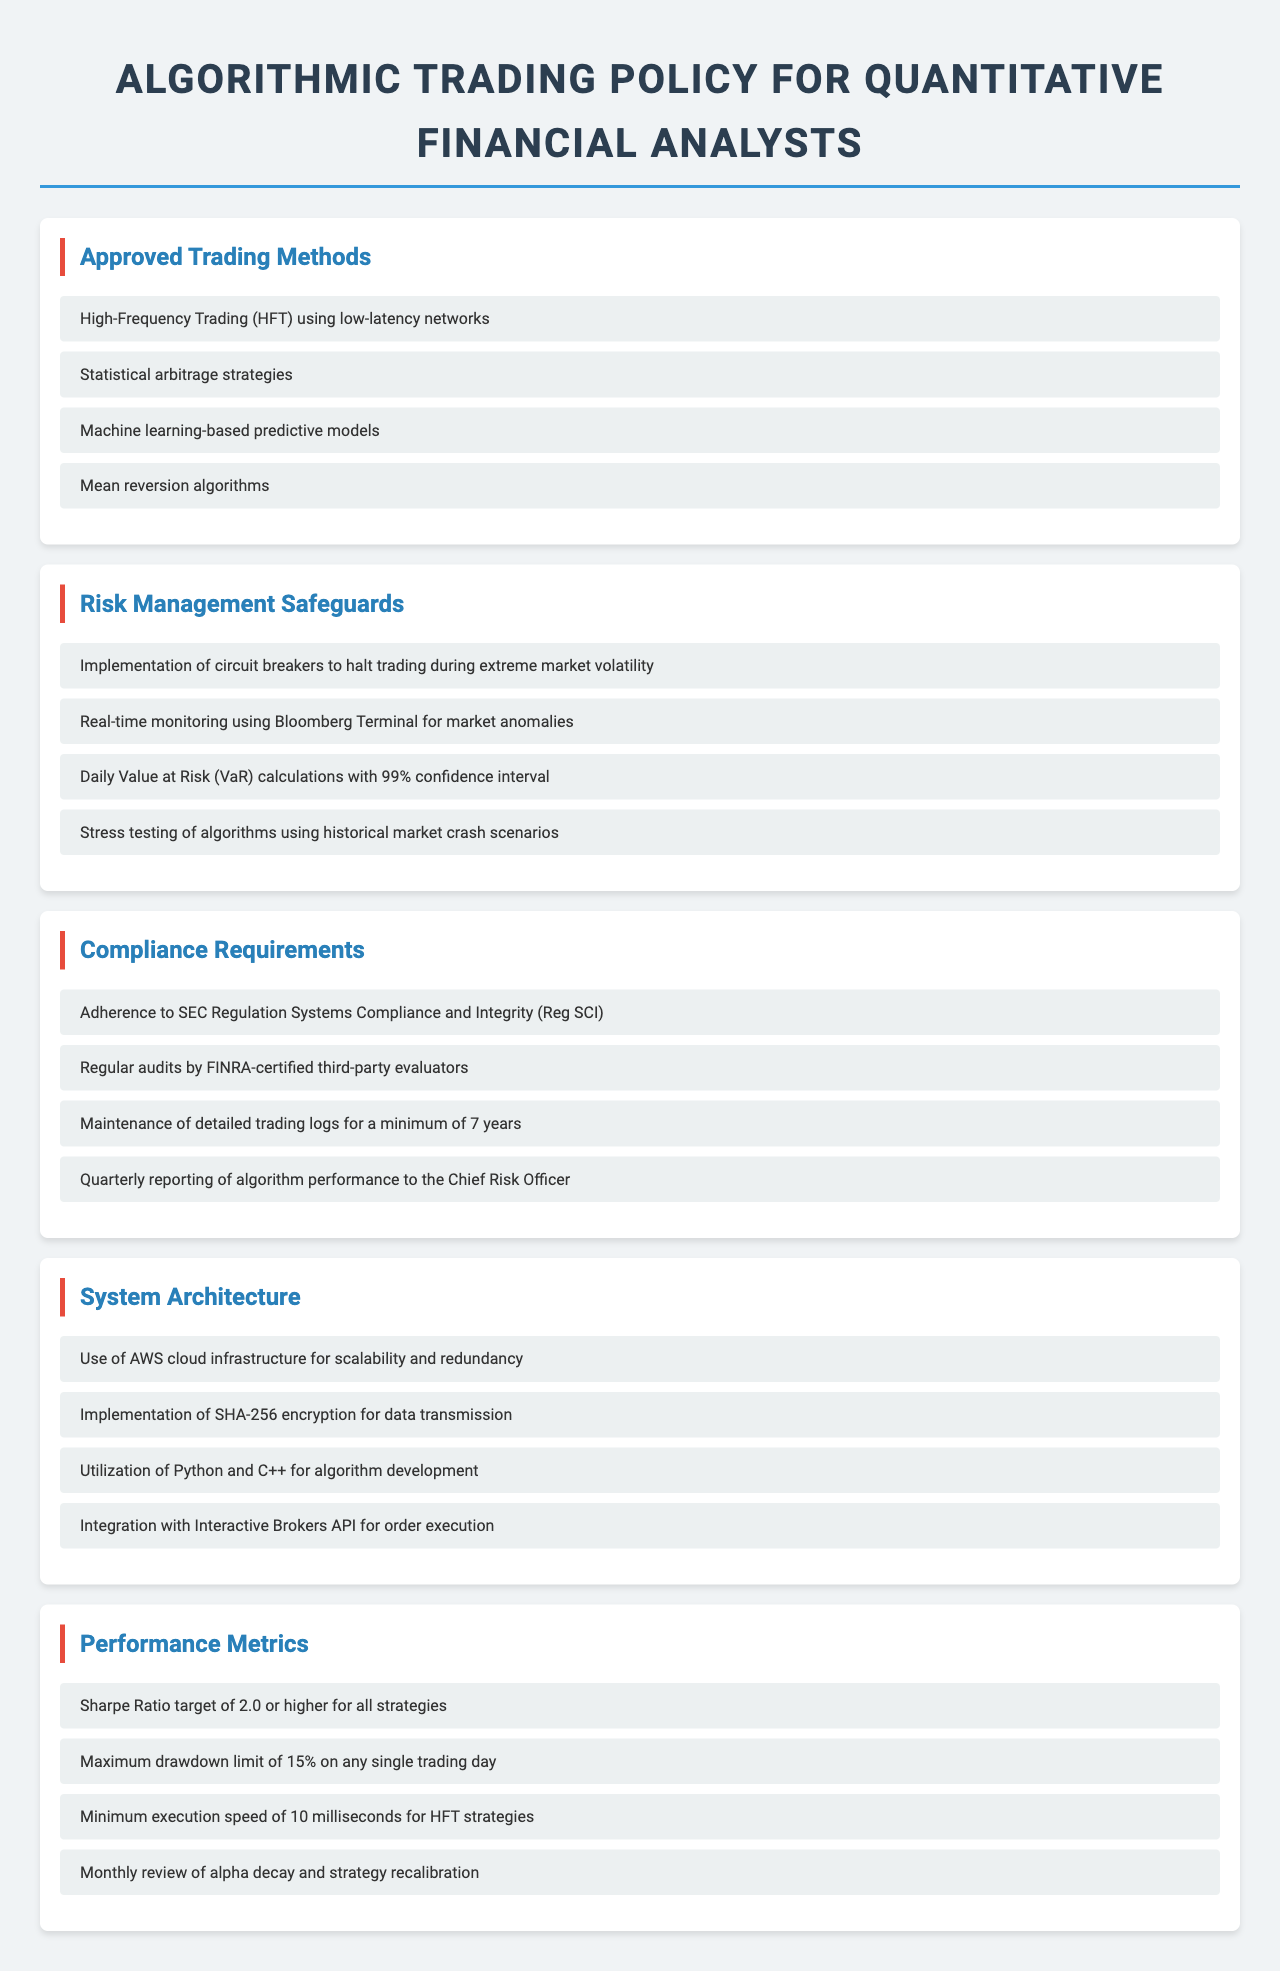What are the approved trading methods? The document lists four approved trading methods under the "Approved Trading Methods" section.
Answer: High-Frequency Trading, Statistical arbitrage strategies, Machine learning-based predictive models, Mean reversion algorithms What safeguard is implemented for extreme market volatility? The document describes safeguards, specifically mentioning circuit breakers.
Answer: Circuit breakers What is the maximum drawdown limit for trading strategies? The document specifies the maximum drawdown limit in the "Performance Metrics" section.
Answer: 15% What is the target Sharpe Ratio for strategies? The document states the target Sharpe Ratio in the "Performance Metrics" section.
Answer: 2.0 Who conducts regular audits of algorithmic trading systems? The compliance requirements mention the entity responsible for audits related to trading systems.
Answer: FINRA-certified third-party evaluators What encryption method is used for data transmission? The document details the encryption method in the "System Architecture" section.
Answer: SHA-256 What is the confidence interval used for Value at Risk calculations? The document explains the confidence interval applied in the daily Value at Risk calculations.
Answer: 99% What is required for algorithm performance reporting? The document mentions a specific requirement in the compliance section regarding performance reporting.
Answer: Quarterly reporting to the Chief Risk Officer 